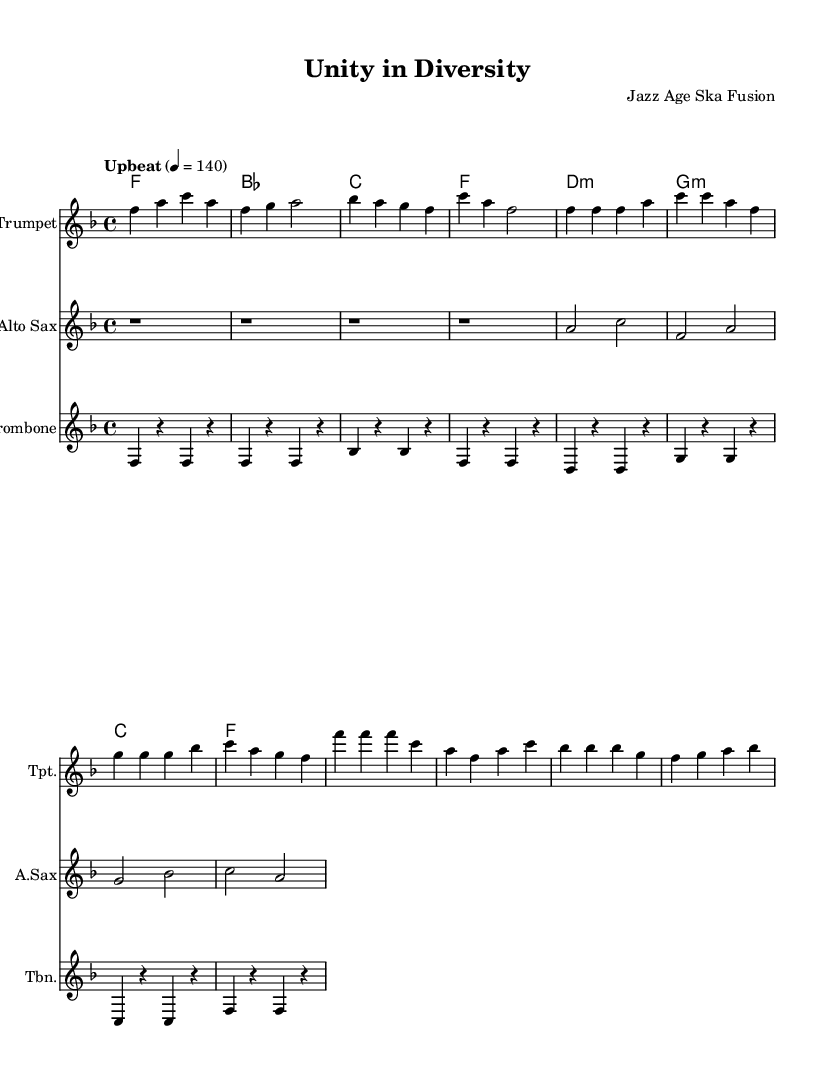What is the key signature of this music? The key signature shown in the music indicates F major, which has one flat (B flat). There are no sharps, just the flat sign for B in the key signature at the beginning of the staff.
Answer: F major What is the time signature of the piece? The time signature is indicated in the beginning part of the staff notation. It displays a '4' over a '4', which means four beats per measure and a quarter note gets one beat.
Answer: 4/4 What is the tempo marking for this piece? The tempo marking is found right at the beginning of the score, specifying the speed of the piece, which says "Upbeat" indicating a lively pace at a quarter note equaling 140 beats per minute.
Answer: Upbeat 4 = 140 What is the main instrument featured in the score? By looking at the various staves, the title and the individual instrument names indicate that the trumpet is the main featured instrument, as it is listed first and has the most prominent melodic material.
Answer: Trumpet How many measures are in the main theme? Counting the measures in the section labeled as the main theme, it consists of four measures indicated with bars separating the musical phrases. Each bar represents one measure, and by counting them you can determine the total number.
Answer: 4 measures What type of chord progression is used in the guitar part? Looking at the guitar chords, they primarily consist of major and minor chords, with clear tonal centers. The progression reflects a common structure in reggae that typically cycles through major and minor chords providing a jazzy feel.
Answer: Major and minor chords What cultural theme is celebrated in this reggae piece? The title "Unity in Diversity" along with the upbeat and festive nature of the music suggests it celebrates cultural diversity, with elements from ska influencing the reggae rhythm. The upbeat character and diversity of instruments also reflect this theme.
Answer: Cultural diversity 